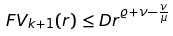Convert formula to latex. <formula><loc_0><loc_0><loc_500><loc_500>\ F V _ { k + 1 } ( r ) \leq D r ^ { \varrho + \nu - \frac { \nu } { \mu } }</formula> 